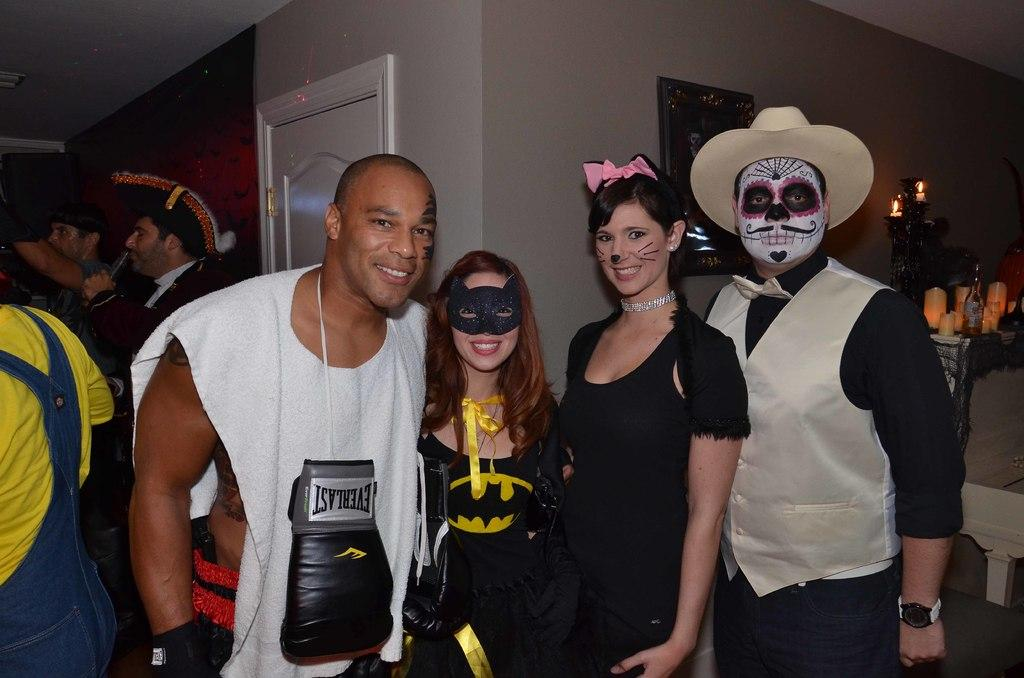Provide a one-sentence caption for the provided image. A man poses with others while in a white shirt with an Everlast glove on the front. 